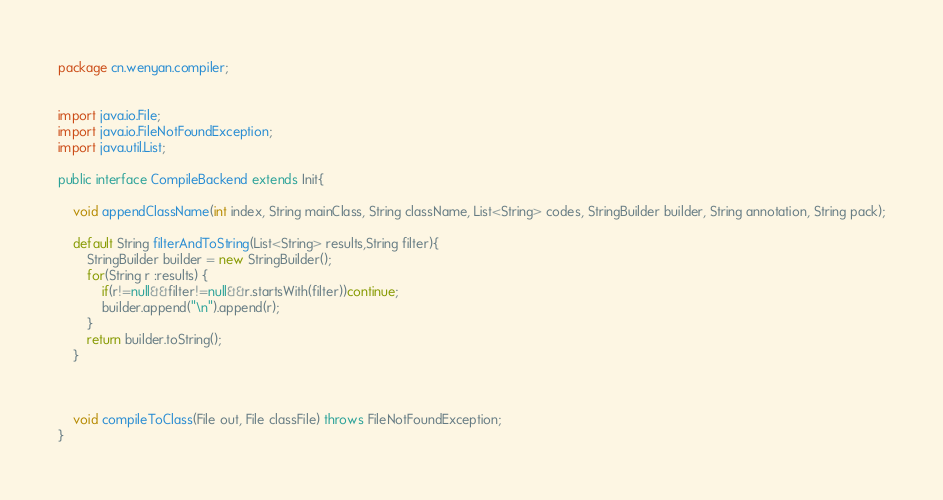Convert code to text. <code><loc_0><loc_0><loc_500><loc_500><_Java_>package cn.wenyan.compiler;


import java.io.File;
import java.io.FileNotFoundException;
import java.util.List;

public interface CompileBackend extends Init{

    void appendClassName(int index, String mainClass, String className, List<String> codes, StringBuilder builder, String annotation, String pack);

    default String filterAndToString(List<String> results,String filter){
        StringBuilder builder = new StringBuilder();
        for(String r :results) {
            if(r!=null&&filter!=null&&r.startsWith(filter))continue;
            builder.append("\n").append(r);
        }
        return builder.toString();
    }



    void compileToClass(File out, File classFile) throws FileNotFoundException;
}
</code> 